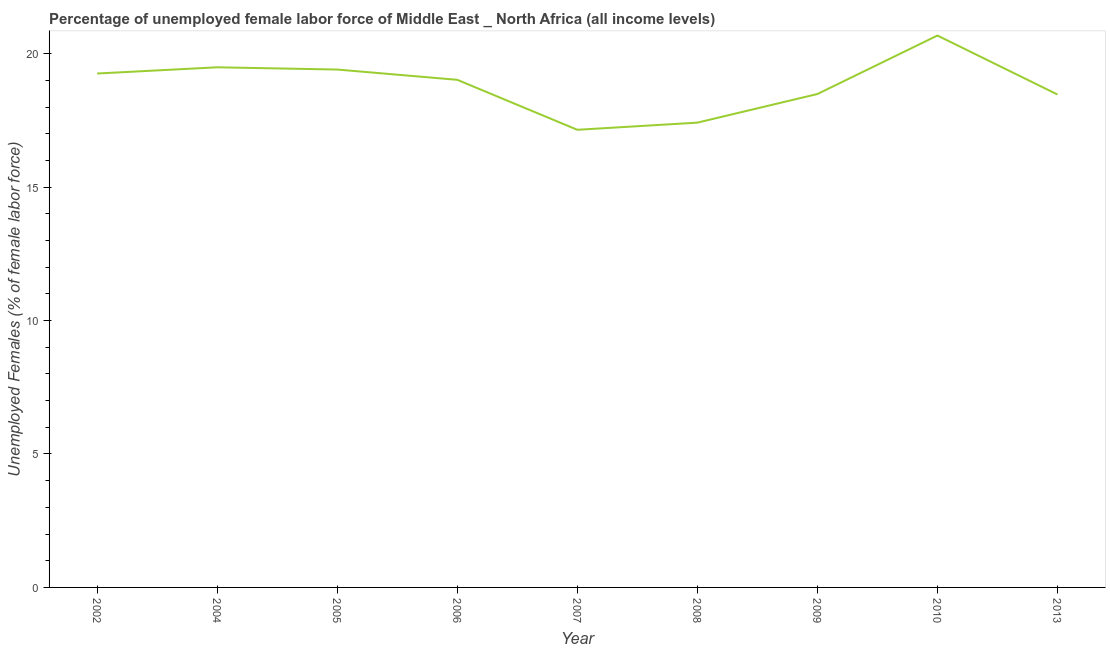What is the total unemployed female labour force in 2004?
Provide a short and direct response. 19.49. Across all years, what is the maximum total unemployed female labour force?
Your response must be concise. 20.68. Across all years, what is the minimum total unemployed female labour force?
Offer a very short reply. 17.15. In which year was the total unemployed female labour force maximum?
Give a very brief answer. 2010. In which year was the total unemployed female labour force minimum?
Your response must be concise. 2007. What is the sum of the total unemployed female labour force?
Offer a very short reply. 169.36. What is the difference between the total unemployed female labour force in 2008 and 2009?
Your answer should be very brief. -1.07. What is the average total unemployed female labour force per year?
Offer a very short reply. 18.82. What is the median total unemployed female labour force?
Keep it short and to the point. 19.02. In how many years, is the total unemployed female labour force greater than 1 %?
Ensure brevity in your answer.  9. Do a majority of the years between 2009 and 2006 (inclusive) have total unemployed female labour force greater than 7 %?
Provide a succinct answer. Yes. What is the ratio of the total unemployed female labour force in 2002 to that in 2004?
Your answer should be very brief. 0.99. Is the total unemployed female labour force in 2005 less than that in 2009?
Make the answer very short. No. Is the difference between the total unemployed female labour force in 2004 and 2008 greater than the difference between any two years?
Offer a very short reply. No. What is the difference between the highest and the second highest total unemployed female labour force?
Provide a short and direct response. 1.19. What is the difference between the highest and the lowest total unemployed female labour force?
Offer a very short reply. 3.53. In how many years, is the total unemployed female labour force greater than the average total unemployed female labour force taken over all years?
Provide a short and direct response. 5. Does the total unemployed female labour force monotonically increase over the years?
Provide a short and direct response. No. How many lines are there?
Your answer should be compact. 1. What is the difference between two consecutive major ticks on the Y-axis?
Your answer should be compact. 5. Does the graph contain grids?
Ensure brevity in your answer.  No. What is the title of the graph?
Your answer should be very brief. Percentage of unemployed female labor force of Middle East _ North Africa (all income levels). What is the label or title of the X-axis?
Provide a short and direct response. Year. What is the label or title of the Y-axis?
Ensure brevity in your answer.  Unemployed Females (% of female labor force). What is the Unemployed Females (% of female labor force) of 2002?
Keep it short and to the point. 19.26. What is the Unemployed Females (% of female labor force) of 2004?
Keep it short and to the point. 19.49. What is the Unemployed Females (% of female labor force) in 2005?
Keep it short and to the point. 19.4. What is the Unemployed Females (% of female labor force) of 2006?
Keep it short and to the point. 19.02. What is the Unemployed Females (% of female labor force) of 2007?
Keep it short and to the point. 17.15. What is the Unemployed Females (% of female labor force) in 2008?
Offer a terse response. 17.41. What is the Unemployed Females (% of female labor force) of 2009?
Your answer should be very brief. 18.49. What is the Unemployed Females (% of female labor force) of 2010?
Your answer should be very brief. 20.68. What is the Unemployed Females (% of female labor force) of 2013?
Offer a terse response. 18.47. What is the difference between the Unemployed Females (% of female labor force) in 2002 and 2004?
Provide a succinct answer. -0.23. What is the difference between the Unemployed Females (% of female labor force) in 2002 and 2005?
Offer a terse response. -0.15. What is the difference between the Unemployed Females (% of female labor force) in 2002 and 2006?
Ensure brevity in your answer.  0.24. What is the difference between the Unemployed Females (% of female labor force) in 2002 and 2007?
Your response must be concise. 2.11. What is the difference between the Unemployed Females (% of female labor force) in 2002 and 2008?
Your response must be concise. 1.84. What is the difference between the Unemployed Females (% of female labor force) in 2002 and 2009?
Give a very brief answer. 0.77. What is the difference between the Unemployed Females (% of female labor force) in 2002 and 2010?
Your answer should be compact. -1.42. What is the difference between the Unemployed Females (% of female labor force) in 2002 and 2013?
Provide a short and direct response. 0.79. What is the difference between the Unemployed Females (% of female labor force) in 2004 and 2005?
Your response must be concise. 0.08. What is the difference between the Unemployed Females (% of female labor force) in 2004 and 2006?
Ensure brevity in your answer.  0.47. What is the difference between the Unemployed Females (% of female labor force) in 2004 and 2007?
Your response must be concise. 2.34. What is the difference between the Unemployed Females (% of female labor force) in 2004 and 2008?
Offer a terse response. 2.07. What is the difference between the Unemployed Females (% of female labor force) in 2004 and 2009?
Keep it short and to the point. 1. What is the difference between the Unemployed Females (% of female labor force) in 2004 and 2010?
Provide a succinct answer. -1.19. What is the difference between the Unemployed Females (% of female labor force) in 2004 and 2013?
Ensure brevity in your answer.  1.02. What is the difference between the Unemployed Females (% of female labor force) in 2005 and 2006?
Offer a very short reply. 0.38. What is the difference between the Unemployed Females (% of female labor force) in 2005 and 2007?
Make the answer very short. 2.26. What is the difference between the Unemployed Females (% of female labor force) in 2005 and 2008?
Your answer should be compact. 1.99. What is the difference between the Unemployed Females (% of female labor force) in 2005 and 2009?
Your answer should be very brief. 0.92. What is the difference between the Unemployed Females (% of female labor force) in 2005 and 2010?
Keep it short and to the point. -1.27. What is the difference between the Unemployed Females (% of female labor force) in 2005 and 2013?
Provide a short and direct response. 0.94. What is the difference between the Unemployed Females (% of female labor force) in 2006 and 2007?
Provide a short and direct response. 1.87. What is the difference between the Unemployed Females (% of female labor force) in 2006 and 2008?
Your response must be concise. 1.6. What is the difference between the Unemployed Females (% of female labor force) in 2006 and 2009?
Offer a very short reply. 0.53. What is the difference between the Unemployed Females (% of female labor force) in 2006 and 2010?
Your response must be concise. -1.66. What is the difference between the Unemployed Females (% of female labor force) in 2006 and 2013?
Your response must be concise. 0.55. What is the difference between the Unemployed Females (% of female labor force) in 2007 and 2008?
Offer a terse response. -0.27. What is the difference between the Unemployed Females (% of female labor force) in 2007 and 2009?
Make the answer very short. -1.34. What is the difference between the Unemployed Females (% of female labor force) in 2007 and 2010?
Give a very brief answer. -3.53. What is the difference between the Unemployed Females (% of female labor force) in 2007 and 2013?
Offer a very short reply. -1.32. What is the difference between the Unemployed Females (% of female labor force) in 2008 and 2009?
Your answer should be very brief. -1.07. What is the difference between the Unemployed Females (% of female labor force) in 2008 and 2010?
Offer a terse response. -3.26. What is the difference between the Unemployed Females (% of female labor force) in 2008 and 2013?
Offer a terse response. -1.05. What is the difference between the Unemployed Females (% of female labor force) in 2009 and 2010?
Your response must be concise. -2.19. What is the difference between the Unemployed Females (% of female labor force) in 2009 and 2013?
Keep it short and to the point. 0.02. What is the difference between the Unemployed Females (% of female labor force) in 2010 and 2013?
Offer a very short reply. 2.21. What is the ratio of the Unemployed Females (% of female labor force) in 2002 to that in 2005?
Offer a very short reply. 0.99. What is the ratio of the Unemployed Females (% of female labor force) in 2002 to that in 2006?
Your response must be concise. 1.01. What is the ratio of the Unemployed Females (% of female labor force) in 2002 to that in 2007?
Give a very brief answer. 1.12. What is the ratio of the Unemployed Females (% of female labor force) in 2002 to that in 2008?
Your answer should be very brief. 1.11. What is the ratio of the Unemployed Females (% of female labor force) in 2002 to that in 2009?
Offer a very short reply. 1.04. What is the ratio of the Unemployed Females (% of female labor force) in 2002 to that in 2010?
Give a very brief answer. 0.93. What is the ratio of the Unemployed Females (% of female labor force) in 2002 to that in 2013?
Provide a succinct answer. 1.04. What is the ratio of the Unemployed Females (% of female labor force) in 2004 to that in 2006?
Your answer should be very brief. 1.02. What is the ratio of the Unemployed Females (% of female labor force) in 2004 to that in 2007?
Your answer should be compact. 1.14. What is the ratio of the Unemployed Females (% of female labor force) in 2004 to that in 2008?
Your answer should be compact. 1.12. What is the ratio of the Unemployed Females (% of female labor force) in 2004 to that in 2009?
Offer a terse response. 1.05. What is the ratio of the Unemployed Females (% of female labor force) in 2004 to that in 2010?
Make the answer very short. 0.94. What is the ratio of the Unemployed Females (% of female labor force) in 2004 to that in 2013?
Make the answer very short. 1.05. What is the ratio of the Unemployed Females (% of female labor force) in 2005 to that in 2006?
Give a very brief answer. 1.02. What is the ratio of the Unemployed Females (% of female labor force) in 2005 to that in 2007?
Your answer should be very brief. 1.13. What is the ratio of the Unemployed Females (% of female labor force) in 2005 to that in 2008?
Offer a very short reply. 1.11. What is the ratio of the Unemployed Females (% of female labor force) in 2005 to that in 2009?
Ensure brevity in your answer.  1.05. What is the ratio of the Unemployed Females (% of female labor force) in 2005 to that in 2010?
Provide a succinct answer. 0.94. What is the ratio of the Unemployed Females (% of female labor force) in 2005 to that in 2013?
Your response must be concise. 1.05. What is the ratio of the Unemployed Females (% of female labor force) in 2006 to that in 2007?
Keep it short and to the point. 1.11. What is the ratio of the Unemployed Females (% of female labor force) in 2006 to that in 2008?
Offer a terse response. 1.09. What is the ratio of the Unemployed Females (% of female labor force) in 2006 to that in 2009?
Provide a succinct answer. 1.03. What is the ratio of the Unemployed Females (% of female labor force) in 2006 to that in 2013?
Ensure brevity in your answer.  1.03. What is the ratio of the Unemployed Females (% of female labor force) in 2007 to that in 2009?
Provide a short and direct response. 0.93. What is the ratio of the Unemployed Females (% of female labor force) in 2007 to that in 2010?
Provide a short and direct response. 0.83. What is the ratio of the Unemployed Females (% of female labor force) in 2007 to that in 2013?
Keep it short and to the point. 0.93. What is the ratio of the Unemployed Females (% of female labor force) in 2008 to that in 2009?
Your answer should be very brief. 0.94. What is the ratio of the Unemployed Females (% of female labor force) in 2008 to that in 2010?
Ensure brevity in your answer.  0.84. What is the ratio of the Unemployed Females (% of female labor force) in 2008 to that in 2013?
Provide a succinct answer. 0.94. What is the ratio of the Unemployed Females (% of female labor force) in 2009 to that in 2010?
Ensure brevity in your answer.  0.89. What is the ratio of the Unemployed Females (% of female labor force) in 2009 to that in 2013?
Give a very brief answer. 1. What is the ratio of the Unemployed Females (% of female labor force) in 2010 to that in 2013?
Provide a succinct answer. 1.12. 